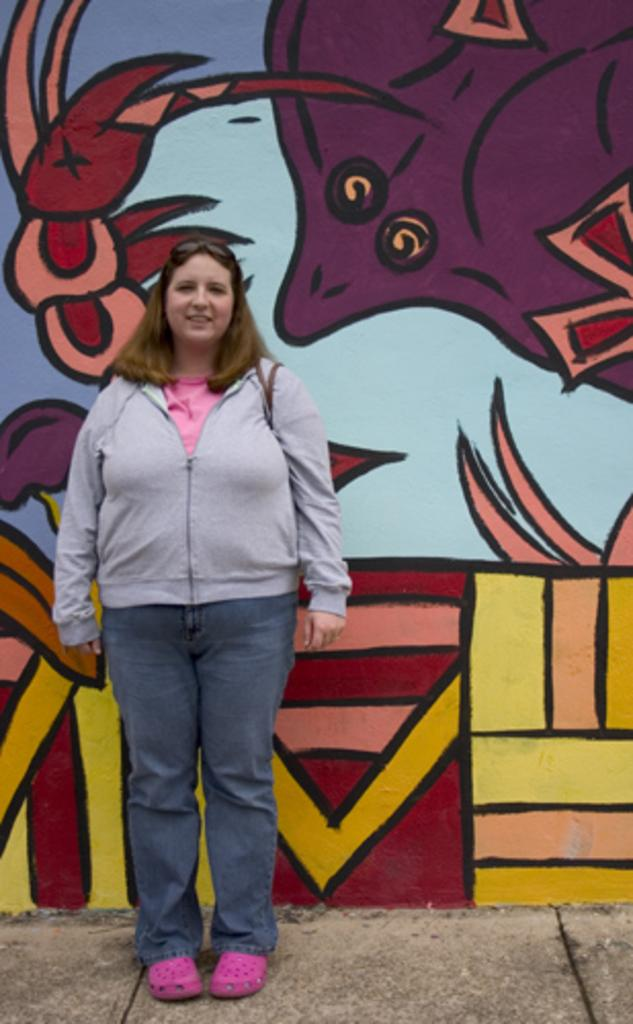What is the person in the image doing? The person is standing in front of a wall. What is the person wearing in the image? The person is wearing a jacket. What can be seen on the wall in the image? There is a painting on the wall. How many trees are visible in the image? There are no trees visible in the image. What is the angle of the person's body in relation to the wall? The angle of the person's body in relation to the wall cannot be determined from the image. 